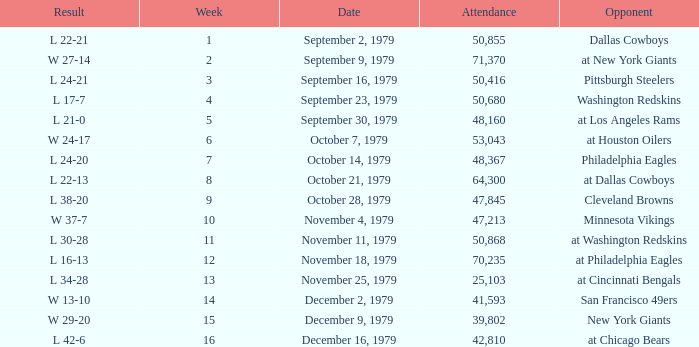What is the highest week when attendance is greater than 64,300 with a result of w 27-14? 2.0. 